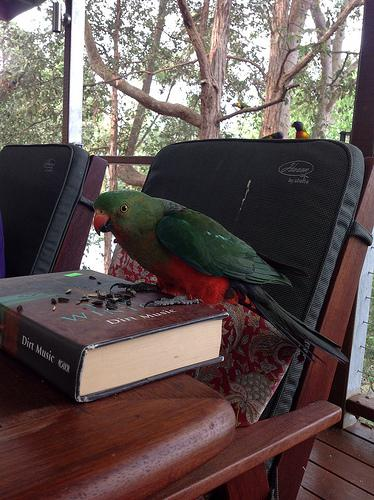Question: what type of bird?
Choices:
A. Lovebird.
B. Canary.
C. Parrot.
D. Finch.
Answer with the letter. Answer: A Question: what color are the cushions?
Choices:
A. Black.
B. Grey.
C. Brown.
D. Red.
Answer with the letter. Answer: B Question: where is the book?
Choices:
A. On floor.
B. On couch.
C. On table.
D. On bed.
Answer with the letter. Answer: C Question: why is the bird eating?
Choices:
A. Bored.
B. Forced.
C. Hungry.
D. Happy.
Answer with the letter. Answer: C 